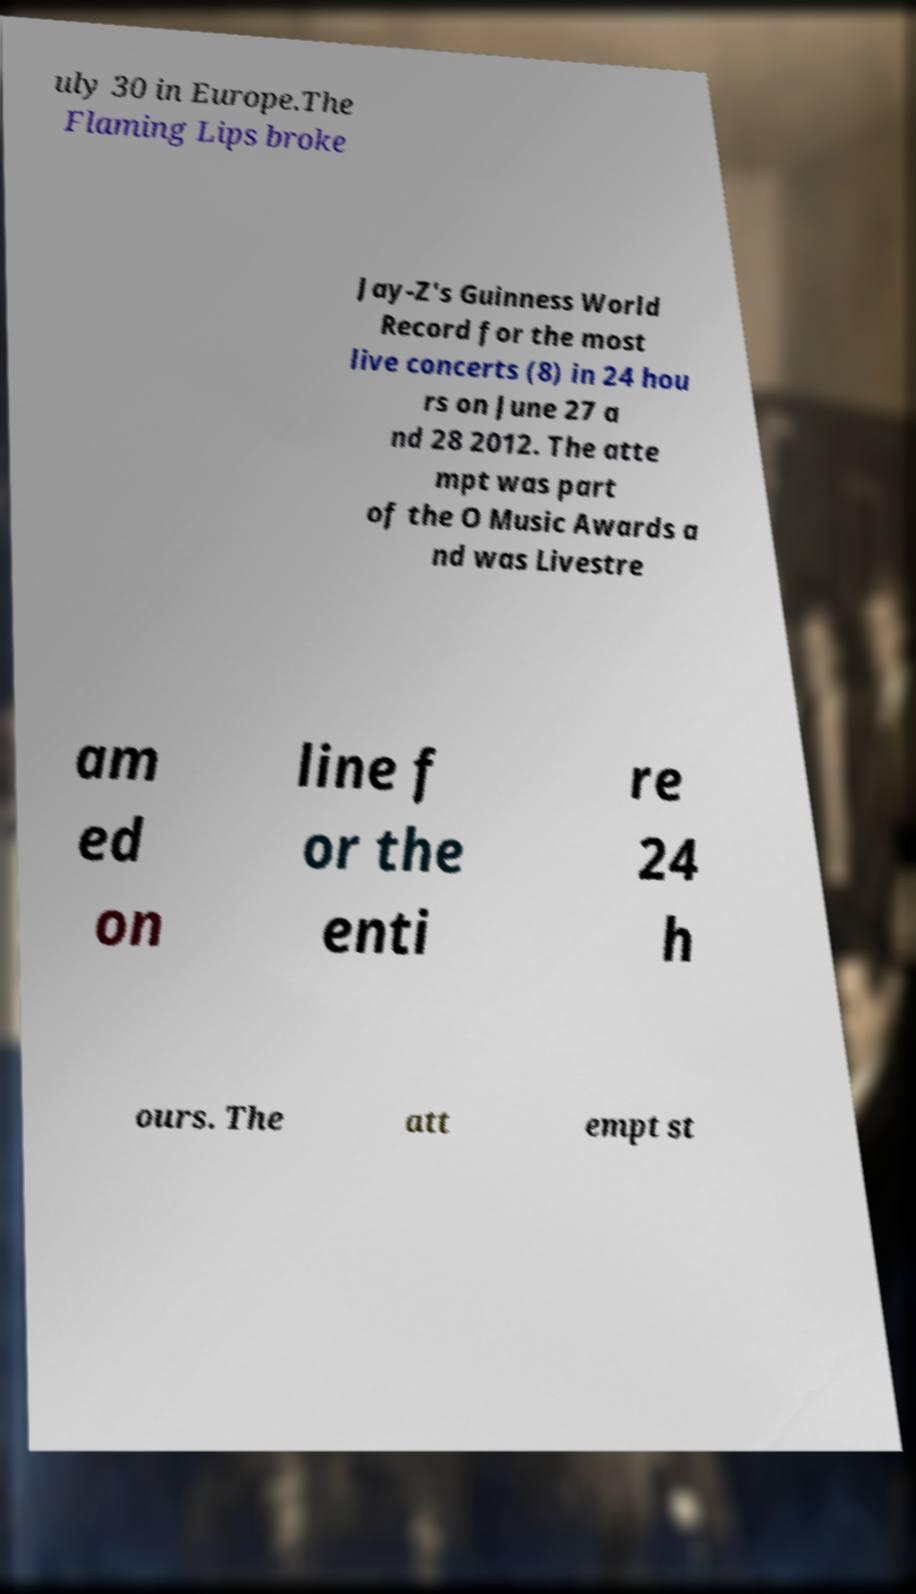I need the written content from this picture converted into text. Can you do that? uly 30 in Europe.The Flaming Lips broke Jay-Z's Guinness World Record for the most live concerts (8) in 24 hou rs on June 27 a nd 28 2012. The atte mpt was part of the O Music Awards a nd was Livestre am ed on line f or the enti re 24 h ours. The att empt st 